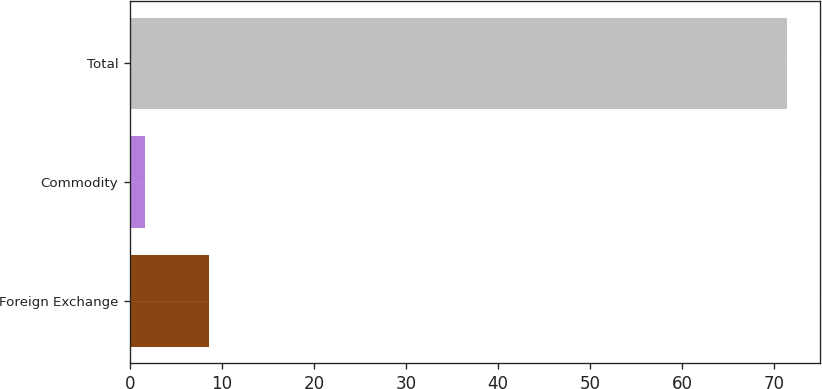Convert chart. <chart><loc_0><loc_0><loc_500><loc_500><bar_chart><fcel>Foreign Exchange<fcel>Commodity<fcel>Total<nl><fcel>8.58<fcel>1.6<fcel>71.4<nl></chart> 